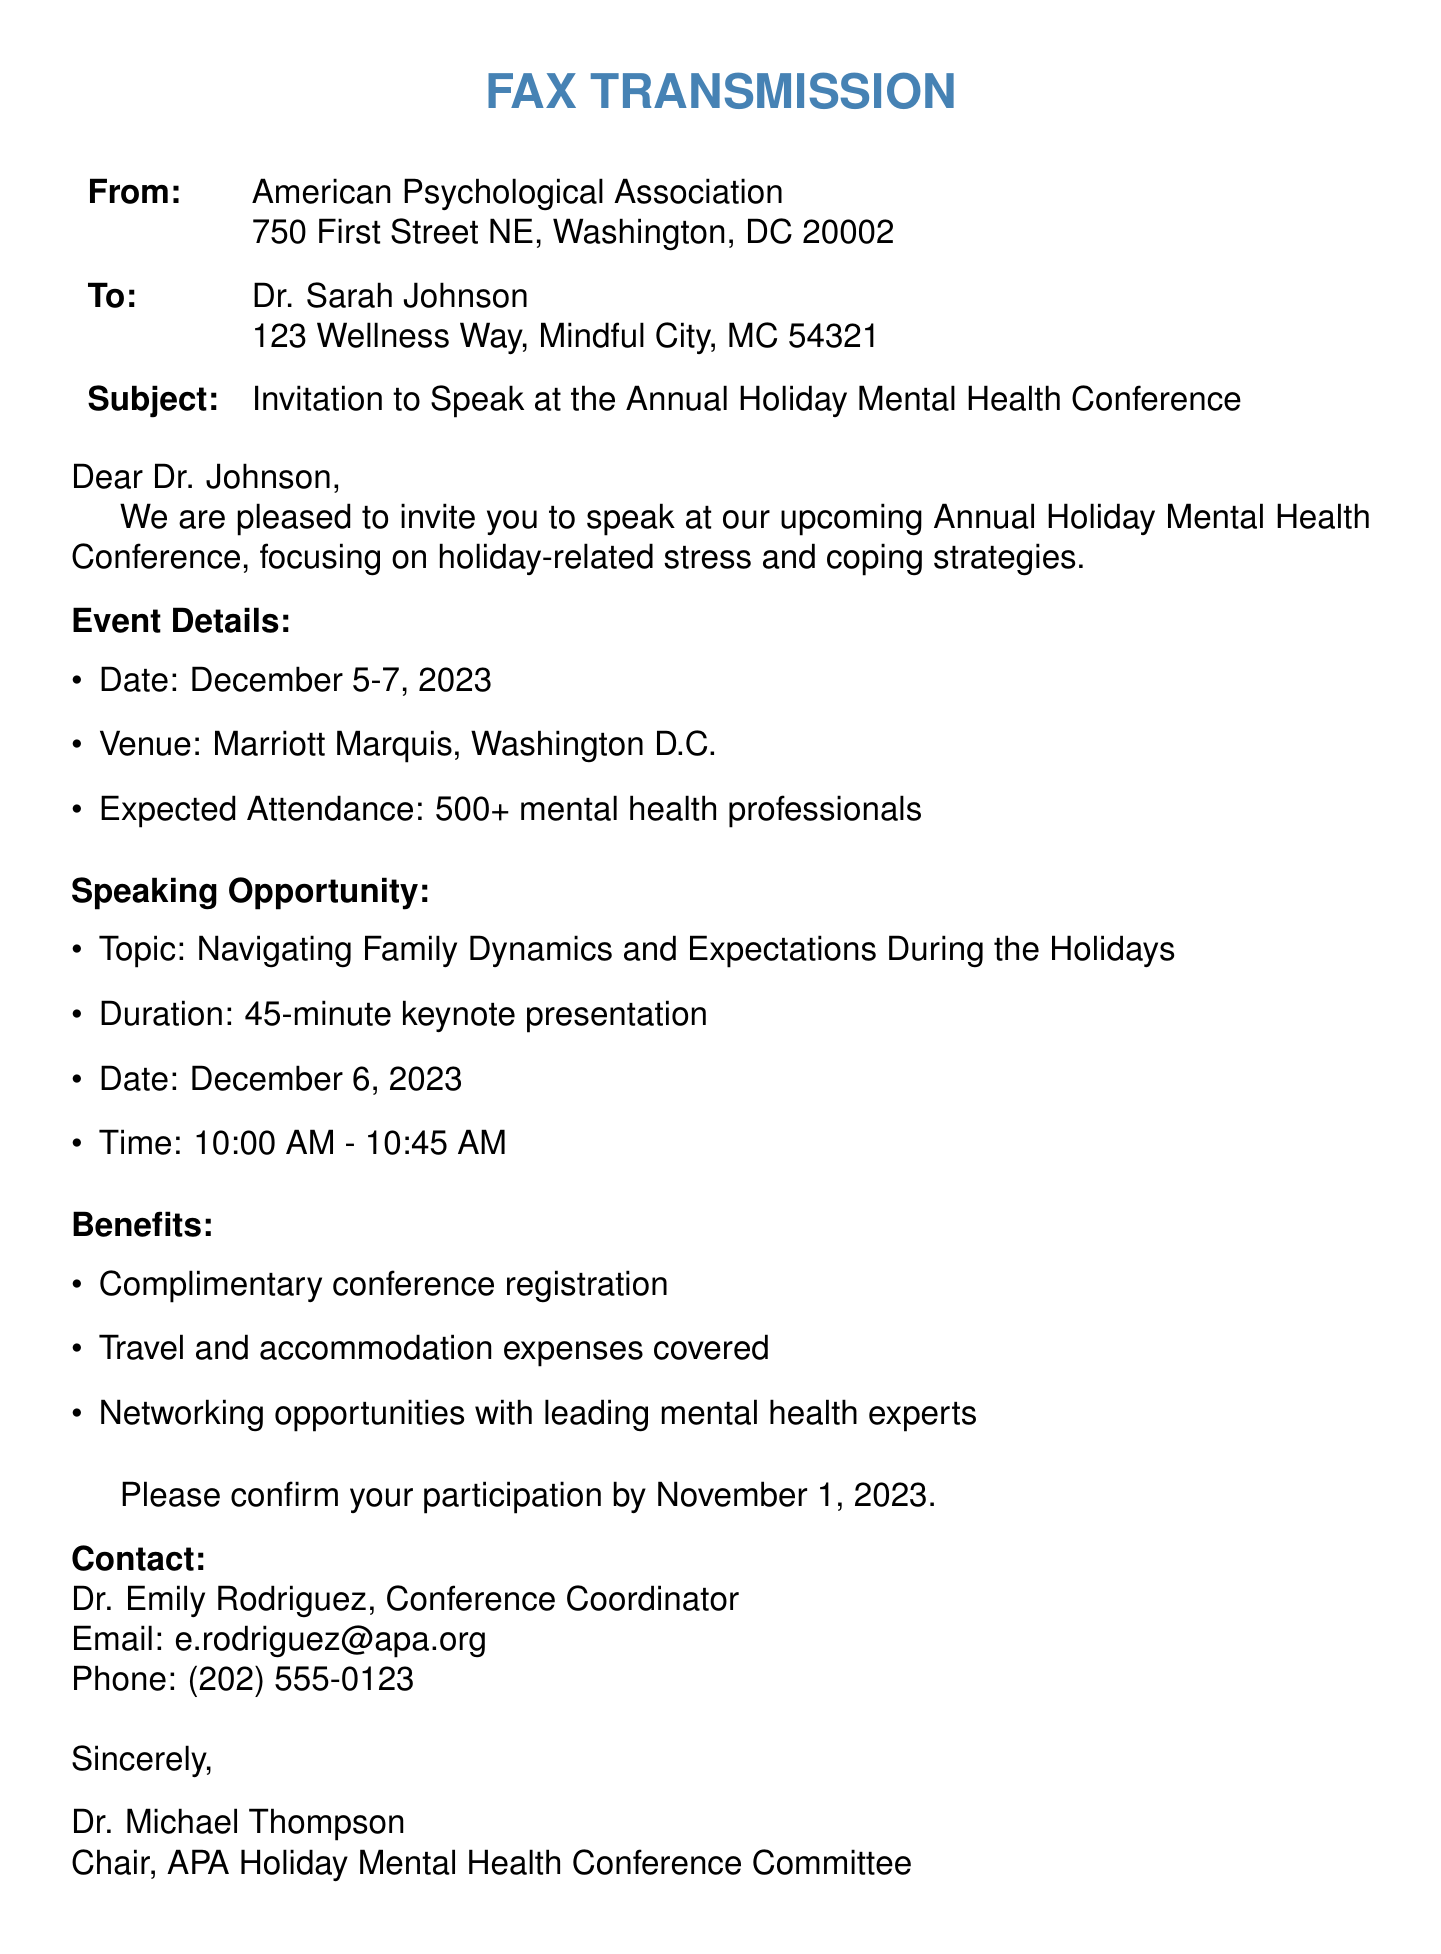What is the name of the conference? The name of the conference is mentioned in the subject line of the fax as the Annual Holiday Mental Health Conference.
Answer: Annual Holiday Mental Health Conference Who is the recipient of the fax? The recipient's name is stated at the beginning of the document as Dr. Sarah Johnson.
Answer: Dr. Sarah Johnson When is the keynote presentation scheduled? The date and time for the keynote presentation are specified in the document, which indicates the presentation is on December 6, 2023, from 10:00 AM to 10:45 AM.
Answer: December 6, 2023, 10:00 AM - 10:45 AM What is the expected attendance for the conference? The fax includes information about the expected number of attendees, indicating there will be 500+ mental health professionals.
Answer: 500+ Who is the contact person for the conference? The document specifies Dr. Emily Rodriguez as the conference coordinator to be contacted.
Answer: Dr. Emily Rodriguez What expenses will be covered for the speakers? The benefits section of the document lists the expenses that will be covered, which includes travel and accommodation expenses.
Answer: Travel and accommodation expenses What topic will Dr. Johnson speak on? The document outlines the speaking opportunity, listing the topic as Navigating Family Dynamics and Expectations During the Holidays.
Answer: Navigating Family Dynamics and Expectations During the Holidays What is the deadline for confirming participation? The document specifies a deadline for confirmation as November 1, 2023.
Answer: November 1, 2023 